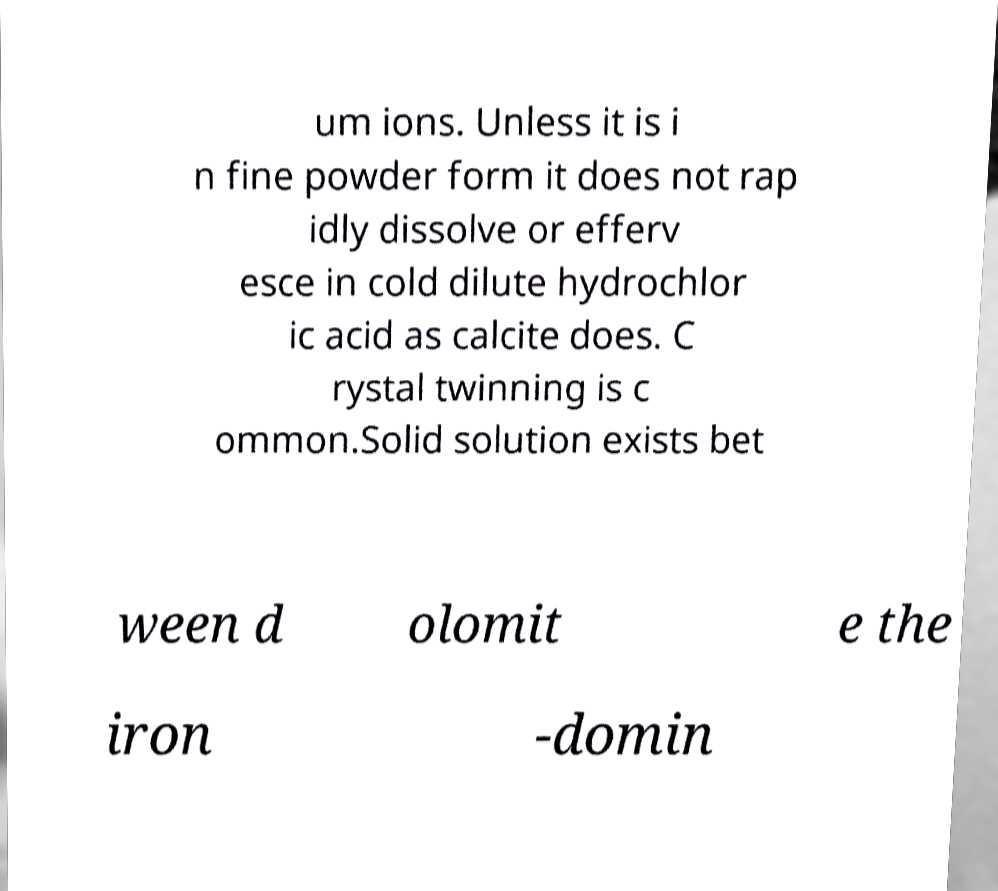Could you extract and type out the text from this image? um ions. Unless it is i n fine powder form it does not rap idly dissolve or efferv esce in cold dilute hydrochlor ic acid as calcite does. C rystal twinning is c ommon.Solid solution exists bet ween d olomit e the iron -domin 